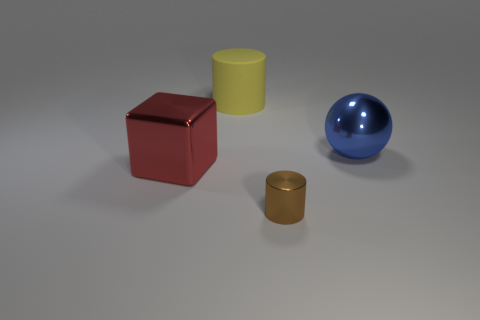Are there any other things that have the same size as the brown shiny thing?
Give a very brief answer. No. The rubber object that is the same size as the red cube is what shape?
Offer a terse response. Cylinder. Are there more brown objects than purple spheres?
Ensure brevity in your answer.  Yes. There is a large metallic thing left of the large rubber cylinder; are there any metallic objects that are right of it?
Provide a short and direct response. Yes. The other thing that is the same shape as the large yellow rubber thing is what color?
Make the answer very short. Brown. Are there any other things that have the same shape as the blue thing?
Keep it short and to the point. No. What color is the cylinder that is made of the same material as the large blue thing?
Your response must be concise. Brown. Are there any large yellow rubber objects that are to the right of the big metal thing in front of the shiny object behind the red cube?
Make the answer very short. Yes. Are there fewer blue metallic things to the left of the brown shiny cylinder than yellow rubber things behind the red shiny cube?
Offer a terse response. Yes. What number of other tiny brown cylinders are made of the same material as the tiny brown cylinder?
Your answer should be very brief. 0. 